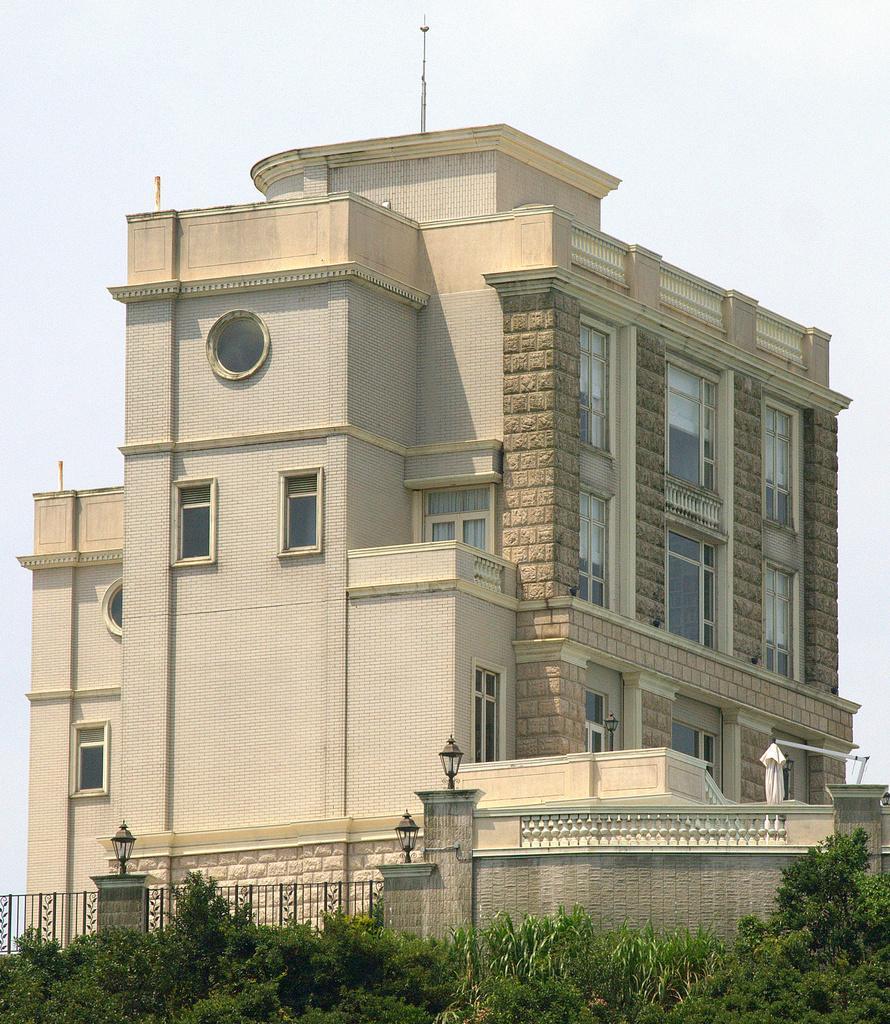Could you give a brief overview of what you see in this image? In this image there is a building. Before it there is a fence to the wall having few lumps on it. Before there are few plants. Top of image there is sky. 